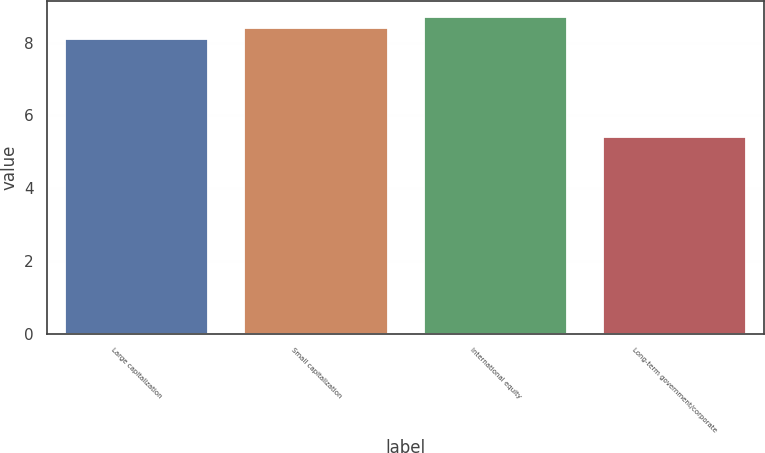<chart> <loc_0><loc_0><loc_500><loc_500><bar_chart><fcel>Large capitalization<fcel>Small capitalization<fcel>International equity<fcel>Long-term government/corporate<nl><fcel>8.1<fcel>8.4<fcel>8.7<fcel>5.4<nl></chart> 